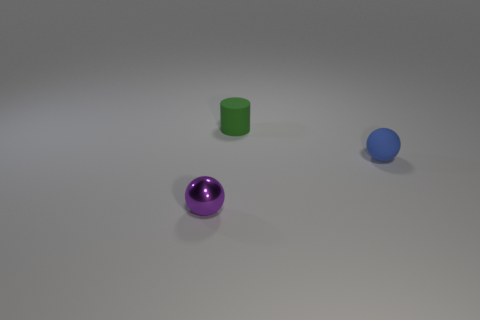Are there any sources of light reflected on the objects? Each object does reflect some light, which helps define their shapes and gives a sense of the environment. The purple sphere, in particular, has a notable highlight indicating a strong light source facing it, but there are no direct reflections that would allow us to identify specific light sources in the image. 